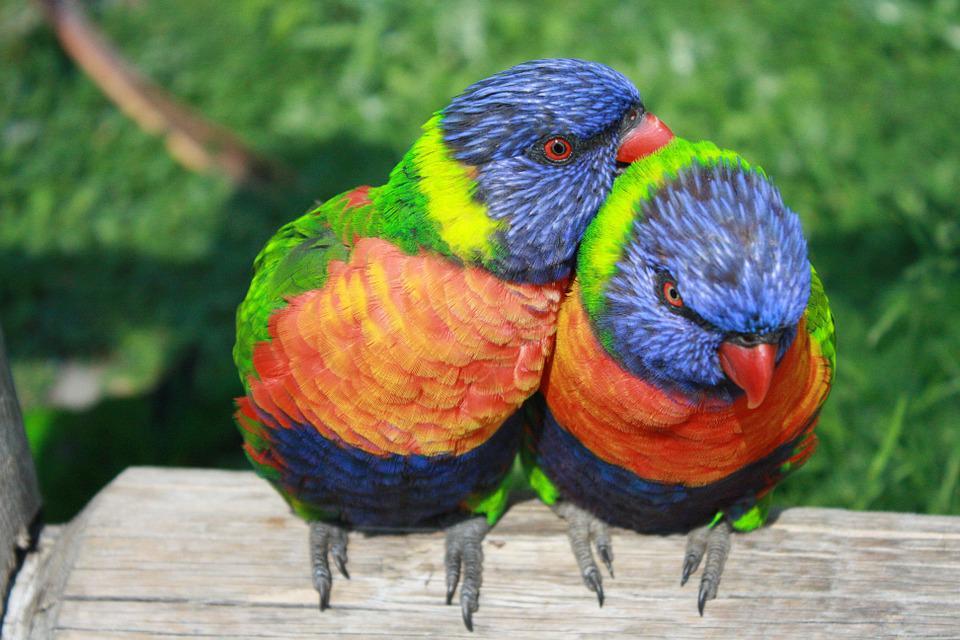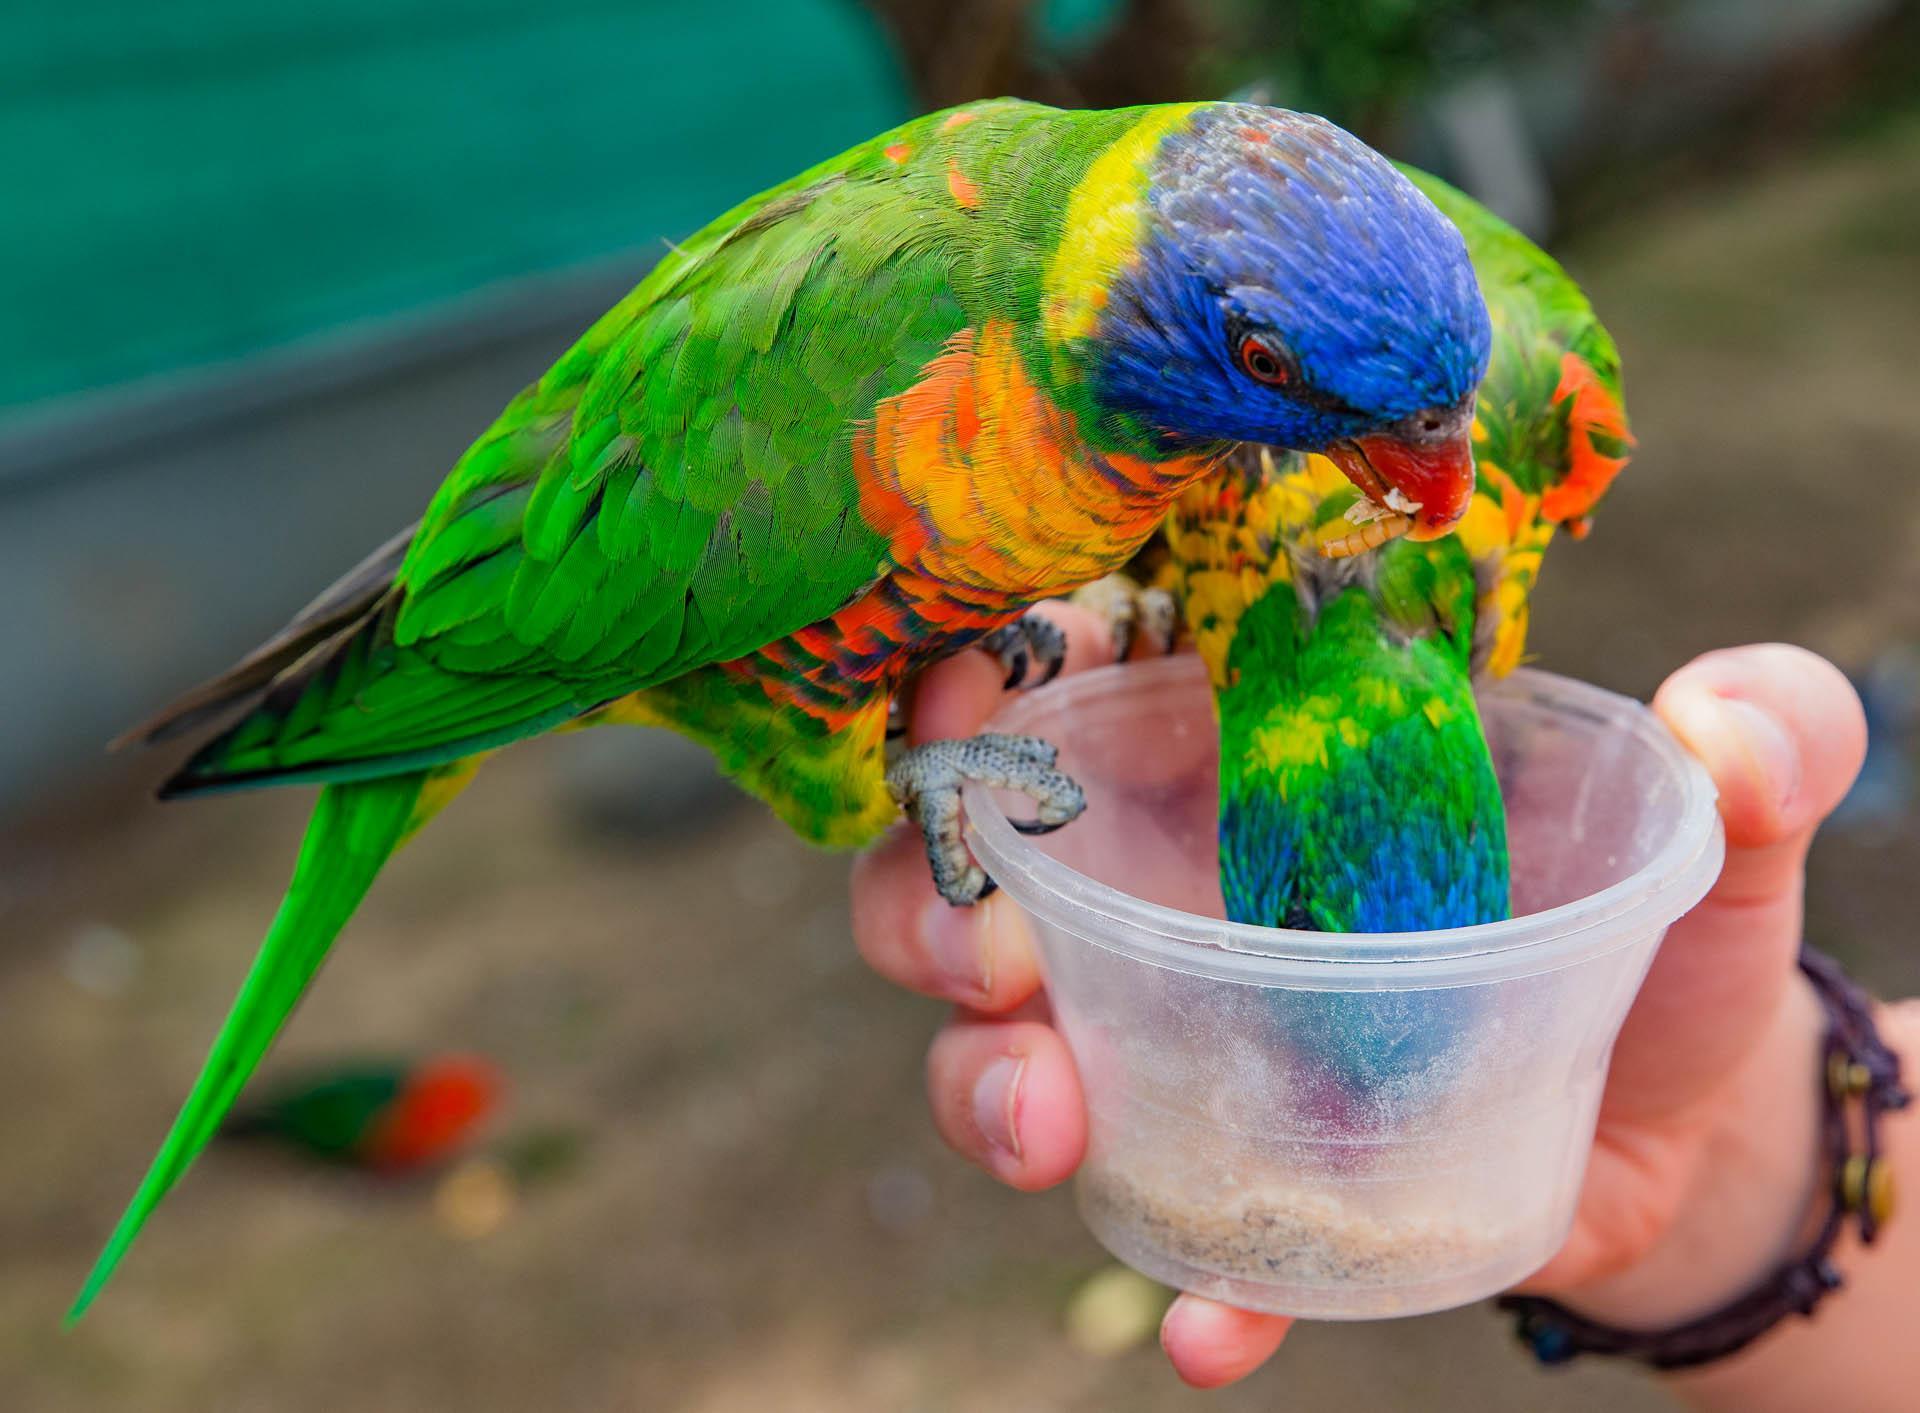The first image is the image on the left, the second image is the image on the right. Considering the images on both sides, is "A person's hand is visible offering a clear plastic cup to one or more colorful birds to feed fro" valid? Answer yes or no. Yes. The first image is the image on the left, the second image is the image on the right. For the images displayed, is the sentence "In one image, a hand is holding a plastic cup out for a parrot." factually correct? Answer yes or no. Yes. 